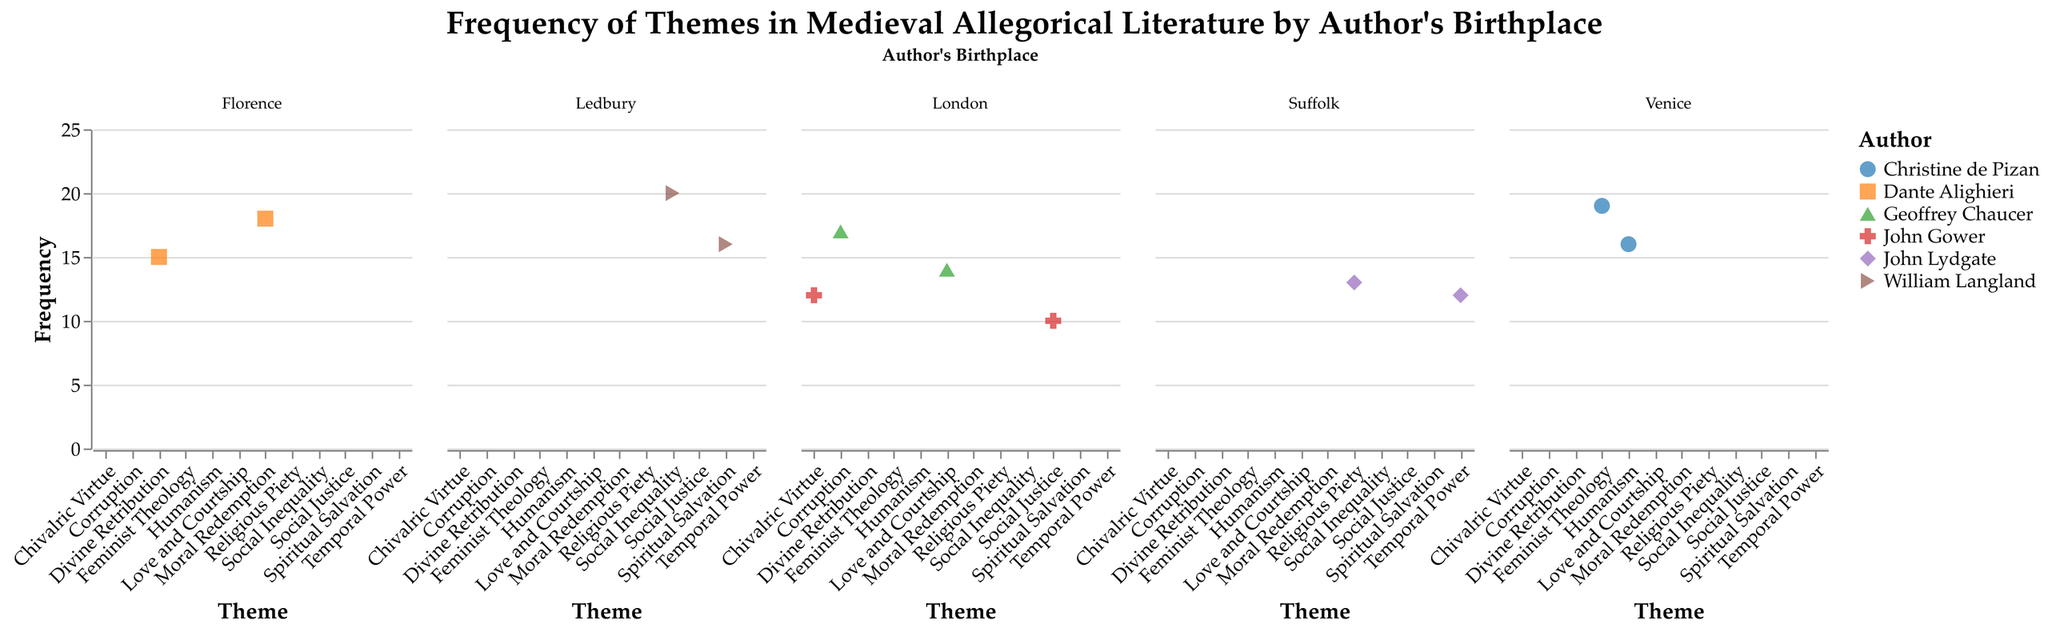What is the theme with the highest frequency in Venice? Look at the subplot for Venice and identify the theme with the highest data point on the y-axis (Frequency value). "Feminist Theology" has a frequency of 19, which is the highest in Venice.
Answer: Feminist Theology How many themes does Geoffrey Chaucer explore in the data set? Identify the data points associated with Geoffrey Chaucer. There are two points, indicating he explores two themes: "Love and Courtship" and "Corruption".
Answer: 2 Which author has the highest total frequency of all themes from London? Sum the frequencies of all themes for each author from London: Geoffrey Chaucer (14 + 17 = 31) and John Gower (12 + 10 = 22). Chaucer has the higher total frequency.
Answer: Geoffrey Chaucer What is the average frequency of themes explored by Dante Alighieri? Sum the frequencies of Dante Alighieri's themes (15 for "Divine Retribution" and 18 for "Moral Redemption") and divide by the number of themes (2). (15 + 18) / 2 = 16.5
Answer: 16.5 Which author's themes in Ledbury show the greatest range in frequency? Calculate the difference between the highest and lowest frequencies for William Langland: 20 for "Social Inequality" and 16 for "Spiritual Salvation". The range is 20 - 16 = 4.
Answer: William Langland Is "Moral Redemption" or "Humanism" explored more frequently, and by how much? Find the frequency of "Moral Redemption" (18) and "Humanism" (16), then subtract the smaller from the larger. 18 - 16 = 2, so "Moral Redemption" is explored more frequently by 2.
Answer: Moral Redemption, by 2 Which birthplace has the theme with the overall highest frequency? Compare the highest frequencies in each subplot: Florence (18), London (17), Ledbury (20), Suffolk (13), and Venice (19). Ledbury has the highest single frequency of 20 for "Social Inequality".
Answer: Ledbury Of the authors from Suffolk, who explores more themes? Count the number of data points for each author in Suffolk. Both points belong to John Lydgate, making him the only author from Suffolk in the dataset.
Answer: John Lydgate Is there any theme with the same frequency represented in more than one subplot? Compare the frequencies of themes across all subplots. "Humanism" in Venice and "Spiritual Salvation" in Ledbury both have a frequency of 16.
Answer: Yes, frequency of 16 How do the frequencies of Chivalric Virtue and Social Justice compare for John Gower? Compare the data points for John Gower: "Chivalric Virtue" has a frequency of 12, and "Social Justice" has a frequency of 10. "Chivalric Virtue" has a higher frequency by 2.
Answer: Chivalric Virtue, by 2 